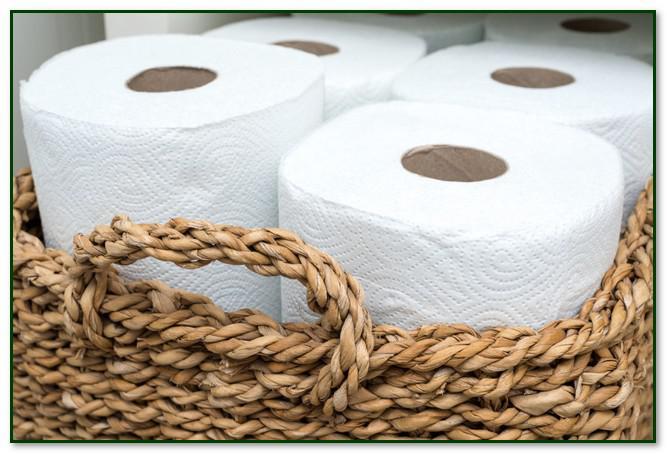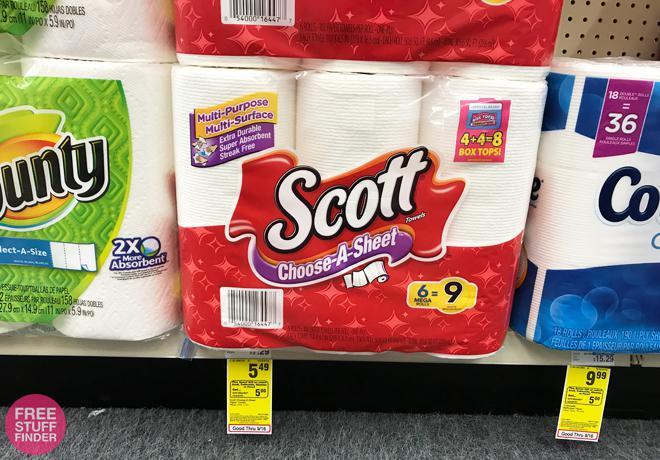The first image is the image on the left, the second image is the image on the right. Analyze the images presented: Is the assertion "In at least one image there is a 6 pack of scott paper towel sitting on a store shelve in mostly red packaging." valid? Answer yes or no. Yes. The first image is the image on the left, the second image is the image on the right. For the images displayed, is the sentence "The right image shows multipacks of paper towels on a store shelf, and includes a pack with the bottom half red." factually correct? Answer yes or no. Yes. 